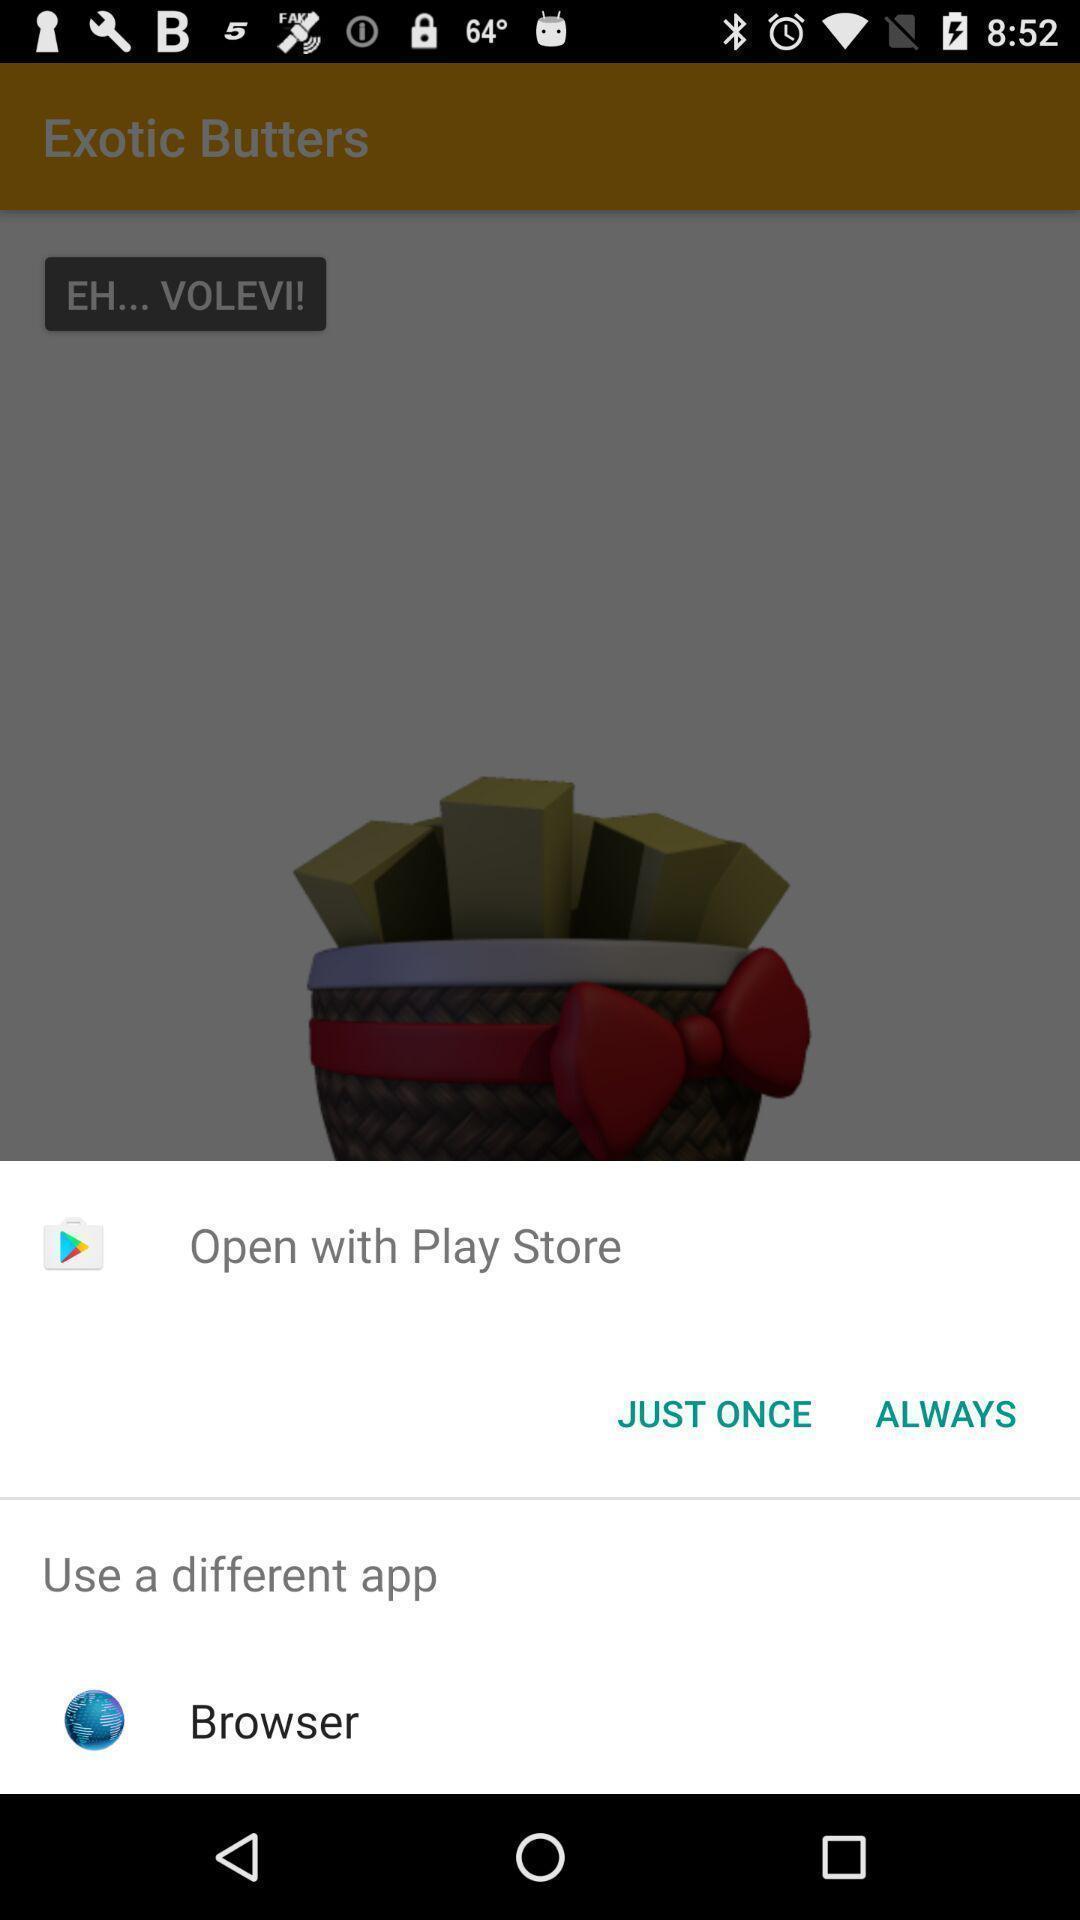Please provide a description for this image. Popup of applications to access the application. 